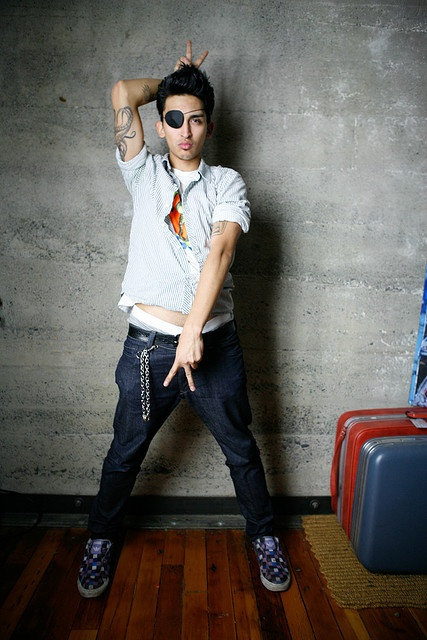Describe the objects in this image and their specific colors. I can see people in black, white, gray, and darkgray tones, suitcase in black, navy, darkblue, and gray tones, and suitcase in black, brown, maroon, and gray tones in this image. 